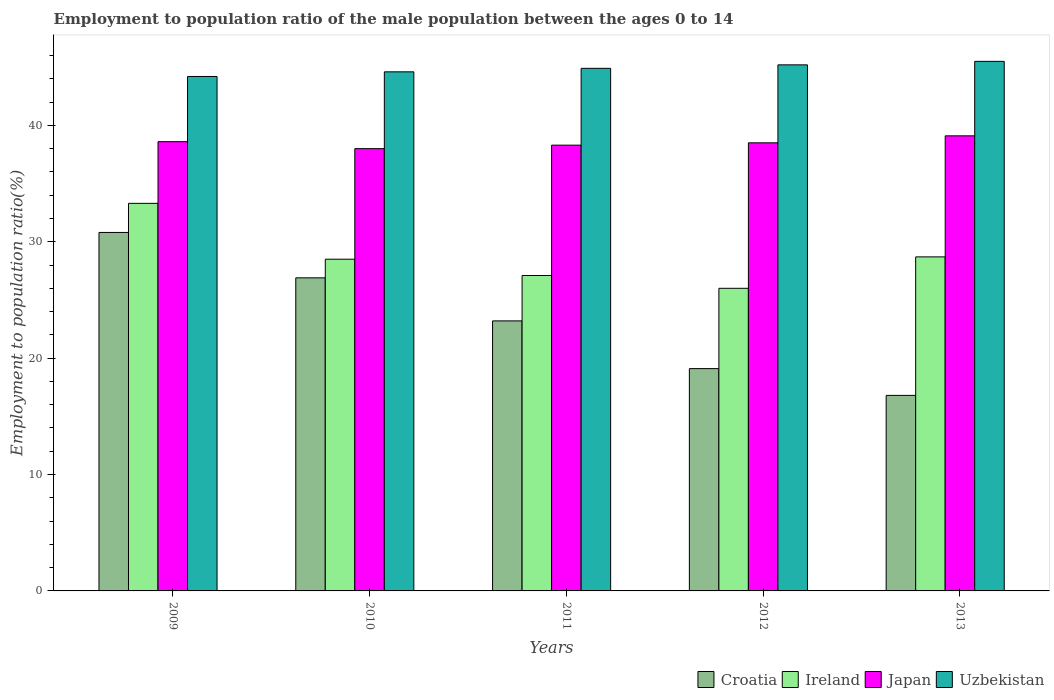Are the number of bars per tick equal to the number of legend labels?
Ensure brevity in your answer.  Yes. How many bars are there on the 3rd tick from the left?
Your response must be concise. 4. What is the label of the 4th group of bars from the left?
Keep it short and to the point. 2012. In how many cases, is the number of bars for a given year not equal to the number of legend labels?
Make the answer very short. 0. What is the employment to population ratio in Uzbekistan in 2012?
Ensure brevity in your answer.  45.2. Across all years, what is the maximum employment to population ratio in Japan?
Your response must be concise. 39.1. Across all years, what is the minimum employment to population ratio in Uzbekistan?
Offer a very short reply. 44.2. In which year was the employment to population ratio in Ireland maximum?
Keep it short and to the point. 2009. What is the total employment to population ratio in Ireland in the graph?
Provide a short and direct response. 143.6. What is the difference between the employment to population ratio in Croatia in 2011 and that in 2013?
Keep it short and to the point. 6.4. What is the difference between the employment to population ratio in Japan in 2012 and the employment to population ratio in Croatia in 2013?
Provide a succinct answer. 21.7. What is the average employment to population ratio in Ireland per year?
Provide a succinct answer. 28.72. In the year 2011, what is the difference between the employment to population ratio in Ireland and employment to population ratio in Japan?
Make the answer very short. -11.2. What is the ratio of the employment to population ratio in Croatia in 2009 to that in 2013?
Make the answer very short. 1.83. What is the difference between the highest and the second highest employment to population ratio in Ireland?
Your answer should be very brief. 4.6. What is the difference between the highest and the lowest employment to population ratio in Uzbekistan?
Your response must be concise. 1.3. In how many years, is the employment to population ratio in Croatia greater than the average employment to population ratio in Croatia taken over all years?
Your answer should be very brief. 2. Is the sum of the employment to population ratio in Uzbekistan in 2010 and 2012 greater than the maximum employment to population ratio in Croatia across all years?
Keep it short and to the point. Yes. What does the 4th bar from the left in 2009 represents?
Make the answer very short. Uzbekistan. What does the 4th bar from the right in 2012 represents?
Your response must be concise. Croatia. Are all the bars in the graph horizontal?
Your answer should be very brief. No. What is the difference between two consecutive major ticks on the Y-axis?
Keep it short and to the point. 10. Where does the legend appear in the graph?
Your answer should be very brief. Bottom right. What is the title of the graph?
Your response must be concise. Employment to population ratio of the male population between the ages 0 to 14. Does "Angola" appear as one of the legend labels in the graph?
Give a very brief answer. No. What is the label or title of the Y-axis?
Offer a terse response. Employment to population ratio(%). What is the Employment to population ratio(%) of Croatia in 2009?
Ensure brevity in your answer.  30.8. What is the Employment to population ratio(%) of Ireland in 2009?
Provide a succinct answer. 33.3. What is the Employment to population ratio(%) in Japan in 2009?
Your answer should be compact. 38.6. What is the Employment to population ratio(%) of Uzbekistan in 2009?
Offer a terse response. 44.2. What is the Employment to population ratio(%) in Croatia in 2010?
Your answer should be compact. 26.9. What is the Employment to population ratio(%) in Japan in 2010?
Provide a succinct answer. 38. What is the Employment to population ratio(%) in Uzbekistan in 2010?
Your answer should be compact. 44.6. What is the Employment to population ratio(%) of Croatia in 2011?
Ensure brevity in your answer.  23.2. What is the Employment to population ratio(%) in Ireland in 2011?
Make the answer very short. 27.1. What is the Employment to population ratio(%) in Japan in 2011?
Ensure brevity in your answer.  38.3. What is the Employment to population ratio(%) of Uzbekistan in 2011?
Ensure brevity in your answer.  44.9. What is the Employment to population ratio(%) of Croatia in 2012?
Ensure brevity in your answer.  19.1. What is the Employment to population ratio(%) of Japan in 2012?
Make the answer very short. 38.5. What is the Employment to population ratio(%) of Uzbekistan in 2012?
Give a very brief answer. 45.2. What is the Employment to population ratio(%) in Croatia in 2013?
Make the answer very short. 16.8. What is the Employment to population ratio(%) of Ireland in 2013?
Your answer should be compact. 28.7. What is the Employment to population ratio(%) of Japan in 2013?
Keep it short and to the point. 39.1. What is the Employment to population ratio(%) of Uzbekistan in 2013?
Ensure brevity in your answer.  45.5. Across all years, what is the maximum Employment to population ratio(%) in Croatia?
Keep it short and to the point. 30.8. Across all years, what is the maximum Employment to population ratio(%) of Ireland?
Keep it short and to the point. 33.3. Across all years, what is the maximum Employment to population ratio(%) in Japan?
Your answer should be compact. 39.1. Across all years, what is the maximum Employment to population ratio(%) of Uzbekistan?
Your answer should be compact. 45.5. Across all years, what is the minimum Employment to population ratio(%) of Croatia?
Keep it short and to the point. 16.8. Across all years, what is the minimum Employment to population ratio(%) in Ireland?
Give a very brief answer. 26. Across all years, what is the minimum Employment to population ratio(%) in Uzbekistan?
Your answer should be compact. 44.2. What is the total Employment to population ratio(%) in Croatia in the graph?
Make the answer very short. 116.8. What is the total Employment to population ratio(%) of Ireland in the graph?
Offer a terse response. 143.6. What is the total Employment to population ratio(%) of Japan in the graph?
Your response must be concise. 192.5. What is the total Employment to population ratio(%) in Uzbekistan in the graph?
Make the answer very short. 224.4. What is the difference between the Employment to population ratio(%) of Ireland in 2009 and that in 2010?
Your answer should be very brief. 4.8. What is the difference between the Employment to population ratio(%) in Japan in 2009 and that in 2010?
Your answer should be compact. 0.6. What is the difference between the Employment to population ratio(%) in Ireland in 2009 and that in 2011?
Your answer should be very brief. 6.2. What is the difference between the Employment to population ratio(%) in Japan in 2009 and that in 2011?
Provide a short and direct response. 0.3. What is the difference between the Employment to population ratio(%) of Uzbekistan in 2009 and that in 2011?
Keep it short and to the point. -0.7. What is the difference between the Employment to population ratio(%) of Croatia in 2009 and that in 2012?
Your answer should be very brief. 11.7. What is the difference between the Employment to population ratio(%) in Japan in 2009 and that in 2012?
Provide a succinct answer. 0.1. What is the difference between the Employment to population ratio(%) of Croatia in 2009 and that in 2013?
Your answer should be compact. 14. What is the difference between the Employment to population ratio(%) of Ireland in 2009 and that in 2013?
Ensure brevity in your answer.  4.6. What is the difference between the Employment to population ratio(%) of Uzbekistan in 2009 and that in 2013?
Your answer should be very brief. -1.3. What is the difference between the Employment to population ratio(%) in Croatia in 2010 and that in 2011?
Provide a short and direct response. 3.7. What is the difference between the Employment to population ratio(%) of Ireland in 2010 and that in 2011?
Your response must be concise. 1.4. What is the difference between the Employment to population ratio(%) of Uzbekistan in 2010 and that in 2011?
Make the answer very short. -0.3. What is the difference between the Employment to population ratio(%) of Croatia in 2010 and that in 2012?
Give a very brief answer. 7.8. What is the difference between the Employment to population ratio(%) of Japan in 2010 and that in 2012?
Your response must be concise. -0.5. What is the difference between the Employment to population ratio(%) in Uzbekistan in 2010 and that in 2012?
Keep it short and to the point. -0.6. What is the difference between the Employment to population ratio(%) in Ireland in 2010 and that in 2013?
Your response must be concise. -0.2. What is the difference between the Employment to population ratio(%) in Uzbekistan in 2010 and that in 2013?
Ensure brevity in your answer.  -0.9. What is the difference between the Employment to population ratio(%) of Ireland in 2011 and that in 2012?
Provide a short and direct response. 1.1. What is the difference between the Employment to population ratio(%) of Uzbekistan in 2011 and that in 2012?
Keep it short and to the point. -0.3. What is the difference between the Employment to population ratio(%) of Ireland in 2011 and that in 2013?
Keep it short and to the point. -1.6. What is the difference between the Employment to population ratio(%) in Croatia in 2012 and that in 2013?
Make the answer very short. 2.3. What is the difference between the Employment to population ratio(%) in Uzbekistan in 2012 and that in 2013?
Your answer should be very brief. -0.3. What is the difference between the Employment to population ratio(%) of Ireland in 2009 and the Employment to population ratio(%) of Japan in 2010?
Ensure brevity in your answer.  -4.7. What is the difference between the Employment to population ratio(%) of Japan in 2009 and the Employment to population ratio(%) of Uzbekistan in 2010?
Make the answer very short. -6. What is the difference between the Employment to population ratio(%) in Croatia in 2009 and the Employment to population ratio(%) in Uzbekistan in 2011?
Your response must be concise. -14.1. What is the difference between the Employment to population ratio(%) of Ireland in 2009 and the Employment to population ratio(%) of Japan in 2011?
Your response must be concise. -5. What is the difference between the Employment to population ratio(%) in Japan in 2009 and the Employment to population ratio(%) in Uzbekistan in 2011?
Ensure brevity in your answer.  -6.3. What is the difference between the Employment to population ratio(%) in Croatia in 2009 and the Employment to population ratio(%) in Ireland in 2012?
Make the answer very short. 4.8. What is the difference between the Employment to population ratio(%) in Croatia in 2009 and the Employment to population ratio(%) in Uzbekistan in 2012?
Keep it short and to the point. -14.4. What is the difference between the Employment to population ratio(%) in Croatia in 2009 and the Employment to population ratio(%) in Ireland in 2013?
Keep it short and to the point. 2.1. What is the difference between the Employment to population ratio(%) of Croatia in 2009 and the Employment to population ratio(%) of Uzbekistan in 2013?
Provide a succinct answer. -14.7. What is the difference between the Employment to population ratio(%) of Ireland in 2009 and the Employment to population ratio(%) of Japan in 2013?
Provide a succinct answer. -5.8. What is the difference between the Employment to population ratio(%) of Japan in 2009 and the Employment to population ratio(%) of Uzbekistan in 2013?
Your answer should be compact. -6.9. What is the difference between the Employment to population ratio(%) in Croatia in 2010 and the Employment to population ratio(%) in Japan in 2011?
Make the answer very short. -11.4. What is the difference between the Employment to population ratio(%) in Ireland in 2010 and the Employment to population ratio(%) in Uzbekistan in 2011?
Provide a short and direct response. -16.4. What is the difference between the Employment to population ratio(%) in Japan in 2010 and the Employment to population ratio(%) in Uzbekistan in 2011?
Provide a succinct answer. -6.9. What is the difference between the Employment to population ratio(%) of Croatia in 2010 and the Employment to population ratio(%) of Japan in 2012?
Give a very brief answer. -11.6. What is the difference between the Employment to population ratio(%) in Croatia in 2010 and the Employment to population ratio(%) in Uzbekistan in 2012?
Your answer should be very brief. -18.3. What is the difference between the Employment to population ratio(%) of Ireland in 2010 and the Employment to population ratio(%) of Uzbekistan in 2012?
Your answer should be compact. -16.7. What is the difference between the Employment to population ratio(%) in Croatia in 2010 and the Employment to population ratio(%) in Ireland in 2013?
Provide a short and direct response. -1.8. What is the difference between the Employment to population ratio(%) of Croatia in 2010 and the Employment to population ratio(%) of Uzbekistan in 2013?
Give a very brief answer. -18.6. What is the difference between the Employment to population ratio(%) in Croatia in 2011 and the Employment to population ratio(%) in Ireland in 2012?
Make the answer very short. -2.8. What is the difference between the Employment to population ratio(%) of Croatia in 2011 and the Employment to population ratio(%) of Japan in 2012?
Offer a very short reply. -15.3. What is the difference between the Employment to population ratio(%) of Ireland in 2011 and the Employment to population ratio(%) of Uzbekistan in 2012?
Provide a short and direct response. -18.1. What is the difference between the Employment to population ratio(%) of Japan in 2011 and the Employment to population ratio(%) of Uzbekistan in 2012?
Give a very brief answer. -6.9. What is the difference between the Employment to population ratio(%) in Croatia in 2011 and the Employment to population ratio(%) in Ireland in 2013?
Your answer should be compact. -5.5. What is the difference between the Employment to population ratio(%) of Croatia in 2011 and the Employment to population ratio(%) of Japan in 2013?
Offer a very short reply. -15.9. What is the difference between the Employment to population ratio(%) in Croatia in 2011 and the Employment to population ratio(%) in Uzbekistan in 2013?
Your answer should be very brief. -22.3. What is the difference between the Employment to population ratio(%) in Ireland in 2011 and the Employment to population ratio(%) in Japan in 2013?
Make the answer very short. -12. What is the difference between the Employment to population ratio(%) in Ireland in 2011 and the Employment to population ratio(%) in Uzbekistan in 2013?
Provide a succinct answer. -18.4. What is the difference between the Employment to population ratio(%) in Croatia in 2012 and the Employment to population ratio(%) in Uzbekistan in 2013?
Provide a succinct answer. -26.4. What is the difference between the Employment to population ratio(%) of Ireland in 2012 and the Employment to population ratio(%) of Uzbekistan in 2013?
Give a very brief answer. -19.5. What is the average Employment to population ratio(%) of Croatia per year?
Your answer should be very brief. 23.36. What is the average Employment to population ratio(%) of Ireland per year?
Offer a very short reply. 28.72. What is the average Employment to population ratio(%) in Japan per year?
Ensure brevity in your answer.  38.5. What is the average Employment to population ratio(%) in Uzbekistan per year?
Keep it short and to the point. 44.88. In the year 2009, what is the difference between the Employment to population ratio(%) in Croatia and Employment to population ratio(%) in Japan?
Offer a very short reply. -7.8. In the year 2009, what is the difference between the Employment to population ratio(%) in Ireland and Employment to population ratio(%) in Uzbekistan?
Provide a short and direct response. -10.9. In the year 2010, what is the difference between the Employment to population ratio(%) in Croatia and Employment to population ratio(%) in Japan?
Make the answer very short. -11.1. In the year 2010, what is the difference between the Employment to population ratio(%) in Croatia and Employment to population ratio(%) in Uzbekistan?
Your answer should be very brief. -17.7. In the year 2010, what is the difference between the Employment to population ratio(%) of Ireland and Employment to population ratio(%) of Uzbekistan?
Your answer should be very brief. -16.1. In the year 2011, what is the difference between the Employment to population ratio(%) in Croatia and Employment to population ratio(%) in Ireland?
Provide a short and direct response. -3.9. In the year 2011, what is the difference between the Employment to population ratio(%) in Croatia and Employment to population ratio(%) in Japan?
Your answer should be compact. -15.1. In the year 2011, what is the difference between the Employment to population ratio(%) in Croatia and Employment to population ratio(%) in Uzbekistan?
Provide a short and direct response. -21.7. In the year 2011, what is the difference between the Employment to population ratio(%) of Ireland and Employment to population ratio(%) of Japan?
Your response must be concise. -11.2. In the year 2011, what is the difference between the Employment to population ratio(%) in Ireland and Employment to population ratio(%) in Uzbekistan?
Offer a terse response. -17.8. In the year 2012, what is the difference between the Employment to population ratio(%) in Croatia and Employment to population ratio(%) in Japan?
Offer a very short reply. -19.4. In the year 2012, what is the difference between the Employment to population ratio(%) in Croatia and Employment to population ratio(%) in Uzbekistan?
Keep it short and to the point. -26.1. In the year 2012, what is the difference between the Employment to population ratio(%) of Ireland and Employment to population ratio(%) of Japan?
Keep it short and to the point. -12.5. In the year 2012, what is the difference between the Employment to population ratio(%) of Ireland and Employment to population ratio(%) of Uzbekistan?
Your response must be concise. -19.2. In the year 2012, what is the difference between the Employment to population ratio(%) of Japan and Employment to population ratio(%) of Uzbekistan?
Give a very brief answer. -6.7. In the year 2013, what is the difference between the Employment to population ratio(%) in Croatia and Employment to population ratio(%) in Japan?
Provide a short and direct response. -22.3. In the year 2013, what is the difference between the Employment to population ratio(%) of Croatia and Employment to population ratio(%) of Uzbekistan?
Your answer should be very brief. -28.7. In the year 2013, what is the difference between the Employment to population ratio(%) of Ireland and Employment to population ratio(%) of Uzbekistan?
Provide a succinct answer. -16.8. What is the ratio of the Employment to population ratio(%) in Croatia in 2009 to that in 2010?
Provide a succinct answer. 1.15. What is the ratio of the Employment to population ratio(%) of Ireland in 2009 to that in 2010?
Provide a short and direct response. 1.17. What is the ratio of the Employment to population ratio(%) in Japan in 2009 to that in 2010?
Your answer should be very brief. 1.02. What is the ratio of the Employment to population ratio(%) of Croatia in 2009 to that in 2011?
Your response must be concise. 1.33. What is the ratio of the Employment to population ratio(%) in Ireland in 2009 to that in 2011?
Make the answer very short. 1.23. What is the ratio of the Employment to population ratio(%) of Japan in 2009 to that in 2011?
Provide a succinct answer. 1.01. What is the ratio of the Employment to population ratio(%) of Uzbekistan in 2009 to that in 2011?
Your response must be concise. 0.98. What is the ratio of the Employment to population ratio(%) of Croatia in 2009 to that in 2012?
Make the answer very short. 1.61. What is the ratio of the Employment to population ratio(%) of Ireland in 2009 to that in 2012?
Offer a terse response. 1.28. What is the ratio of the Employment to population ratio(%) in Uzbekistan in 2009 to that in 2012?
Your response must be concise. 0.98. What is the ratio of the Employment to population ratio(%) of Croatia in 2009 to that in 2013?
Make the answer very short. 1.83. What is the ratio of the Employment to population ratio(%) in Ireland in 2009 to that in 2013?
Provide a short and direct response. 1.16. What is the ratio of the Employment to population ratio(%) of Japan in 2009 to that in 2013?
Keep it short and to the point. 0.99. What is the ratio of the Employment to population ratio(%) in Uzbekistan in 2009 to that in 2013?
Give a very brief answer. 0.97. What is the ratio of the Employment to population ratio(%) of Croatia in 2010 to that in 2011?
Your response must be concise. 1.16. What is the ratio of the Employment to population ratio(%) of Ireland in 2010 to that in 2011?
Make the answer very short. 1.05. What is the ratio of the Employment to population ratio(%) of Japan in 2010 to that in 2011?
Your response must be concise. 0.99. What is the ratio of the Employment to population ratio(%) in Croatia in 2010 to that in 2012?
Ensure brevity in your answer.  1.41. What is the ratio of the Employment to population ratio(%) in Ireland in 2010 to that in 2012?
Keep it short and to the point. 1.1. What is the ratio of the Employment to population ratio(%) of Uzbekistan in 2010 to that in 2012?
Provide a succinct answer. 0.99. What is the ratio of the Employment to population ratio(%) of Croatia in 2010 to that in 2013?
Your response must be concise. 1.6. What is the ratio of the Employment to population ratio(%) in Ireland in 2010 to that in 2013?
Your response must be concise. 0.99. What is the ratio of the Employment to population ratio(%) in Japan in 2010 to that in 2013?
Provide a short and direct response. 0.97. What is the ratio of the Employment to population ratio(%) of Uzbekistan in 2010 to that in 2013?
Make the answer very short. 0.98. What is the ratio of the Employment to population ratio(%) in Croatia in 2011 to that in 2012?
Keep it short and to the point. 1.21. What is the ratio of the Employment to population ratio(%) in Ireland in 2011 to that in 2012?
Your answer should be very brief. 1.04. What is the ratio of the Employment to population ratio(%) in Japan in 2011 to that in 2012?
Your answer should be compact. 0.99. What is the ratio of the Employment to population ratio(%) of Croatia in 2011 to that in 2013?
Give a very brief answer. 1.38. What is the ratio of the Employment to population ratio(%) of Ireland in 2011 to that in 2013?
Provide a short and direct response. 0.94. What is the ratio of the Employment to population ratio(%) of Japan in 2011 to that in 2013?
Your answer should be very brief. 0.98. What is the ratio of the Employment to population ratio(%) of Uzbekistan in 2011 to that in 2013?
Give a very brief answer. 0.99. What is the ratio of the Employment to population ratio(%) of Croatia in 2012 to that in 2013?
Make the answer very short. 1.14. What is the ratio of the Employment to population ratio(%) of Ireland in 2012 to that in 2013?
Make the answer very short. 0.91. What is the ratio of the Employment to population ratio(%) of Japan in 2012 to that in 2013?
Ensure brevity in your answer.  0.98. What is the ratio of the Employment to population ratio(%) in Uzbekistan in 2012 to that in 2013?
Offer a very short reply. 0.99. What is the difference between the highest and the second highest Employment to population ratio(%) of Croatia?
Your answer should be very brief. 3.9. What is the difference between the highest and the second highest Employment to population ratio(%) of Ireland?
Offer a terse response. 4.6. What is the difference between the highest and the second highest Employment to population ratio(%) in Uzbekistan?
Keep it short and to the point. 0.3. What is the difference between the highest and the lowest Employment to population ratio(%) in Japan?
Offer a very short reply. 1.1. What is the difference between the highest and the lowest Employment to population ratio(%) in Uzbekistan?
Your answer should be compact. 1.3. 